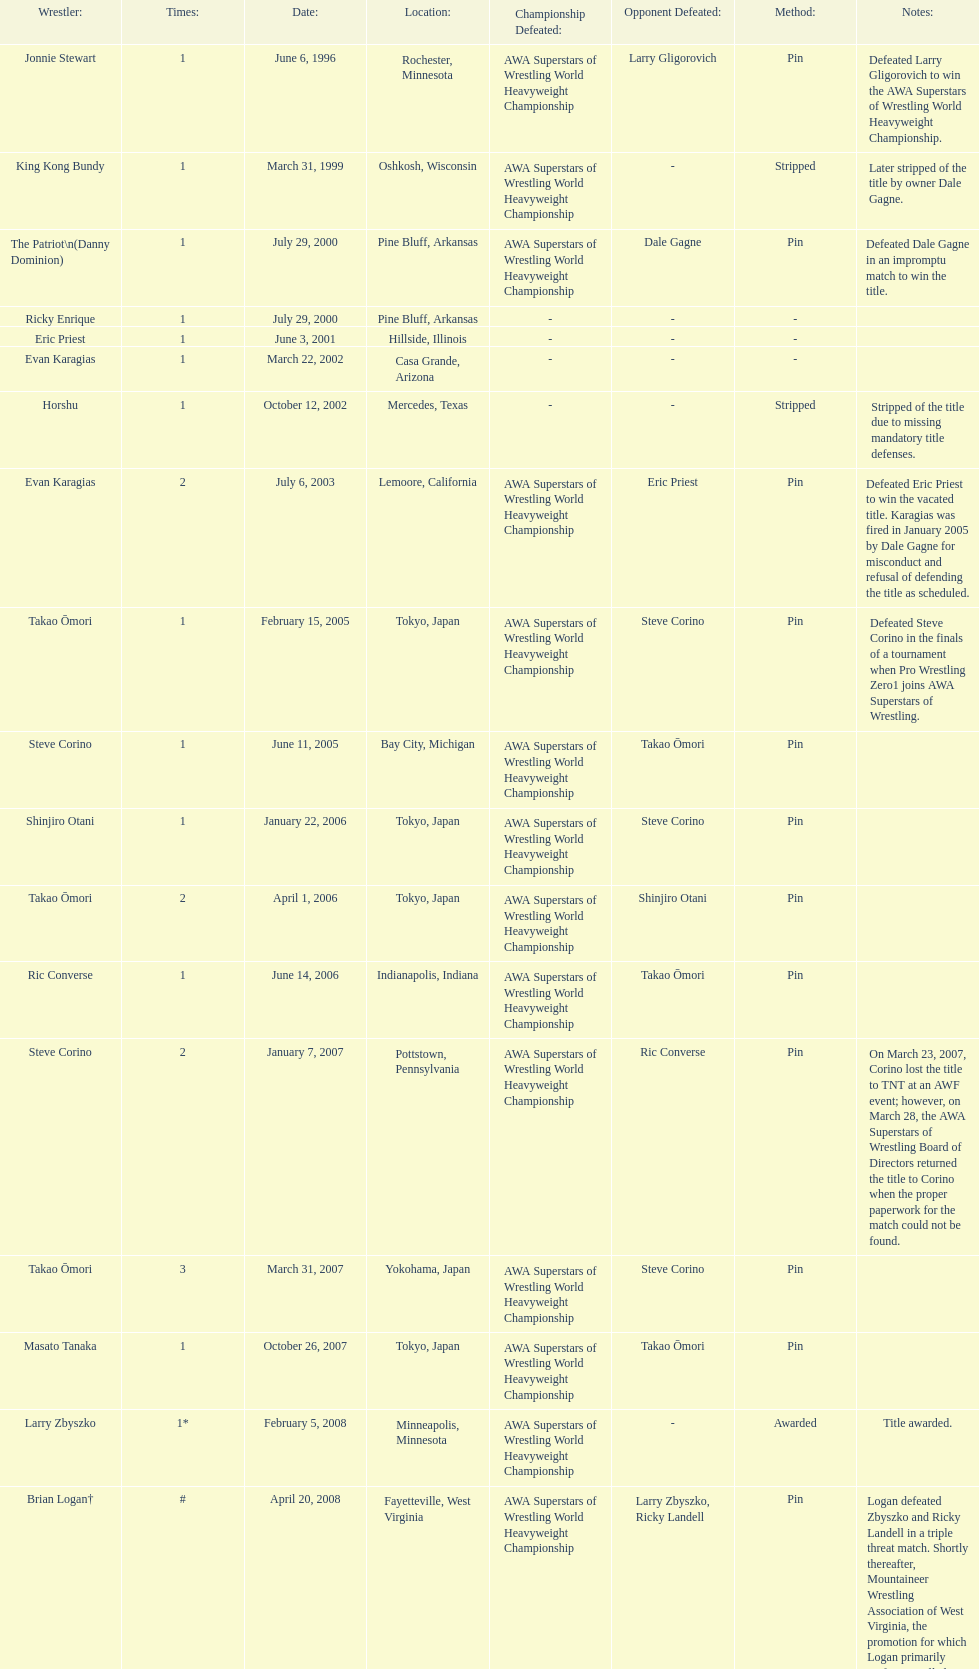How many times has ricky landell held the wsl title? 1. 